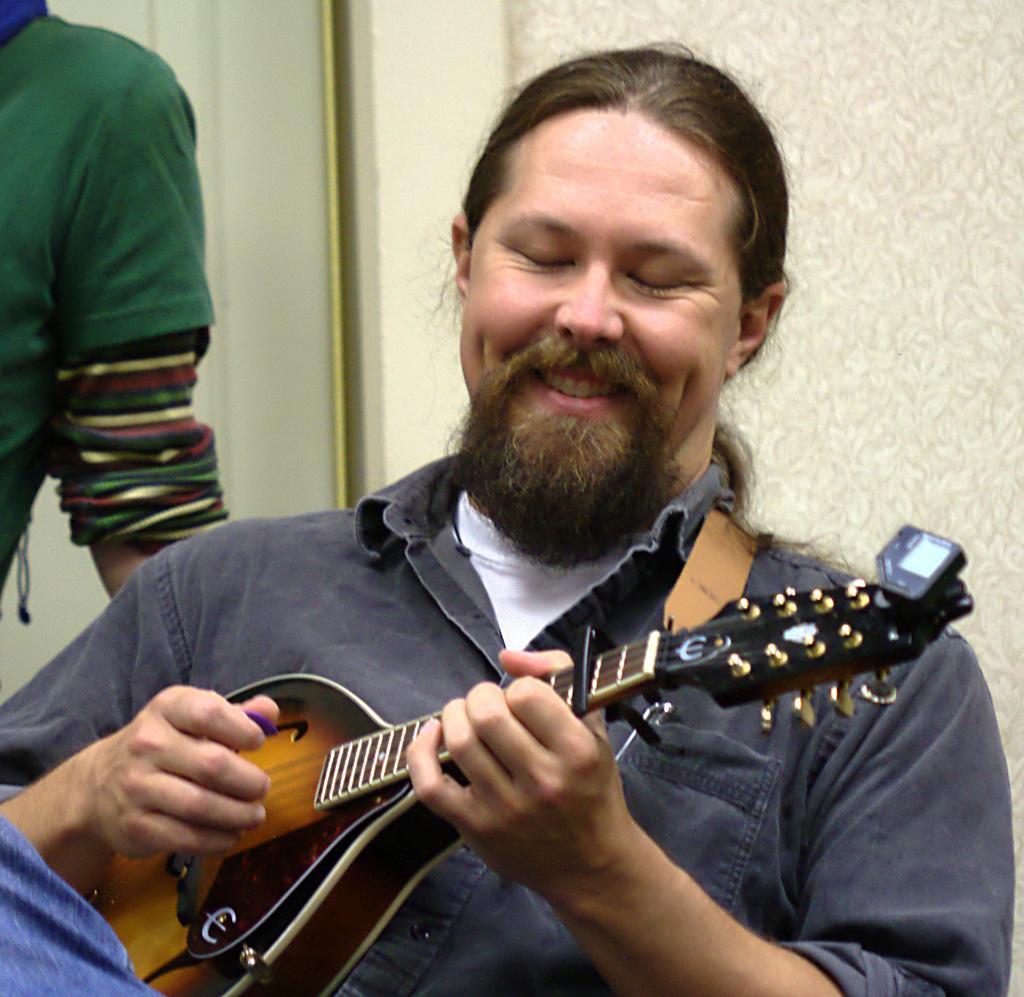Could you give a brief overview of what you see in this image? In this picture we can see a man holding guitar in his hand and playing it and smiling and he is sitting and beside to him we have other person and in the background we can see wall. 